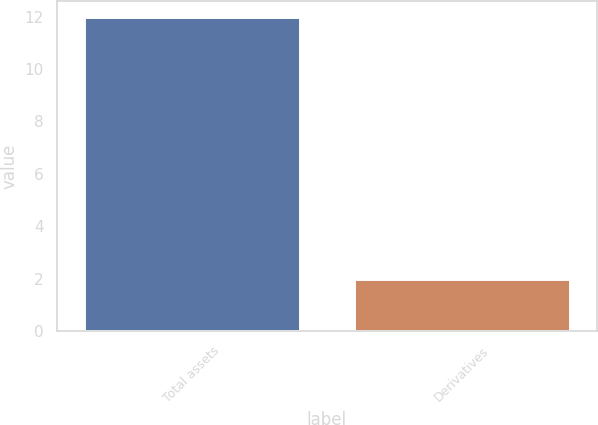Convert chart to OTSL. <chart><loc_0><loc_0><loc_500><loc_500><bar_chart><fcel>Total assets<fcel>Derivatives<nl><fcel>12<fcel>2<nl></chart> 